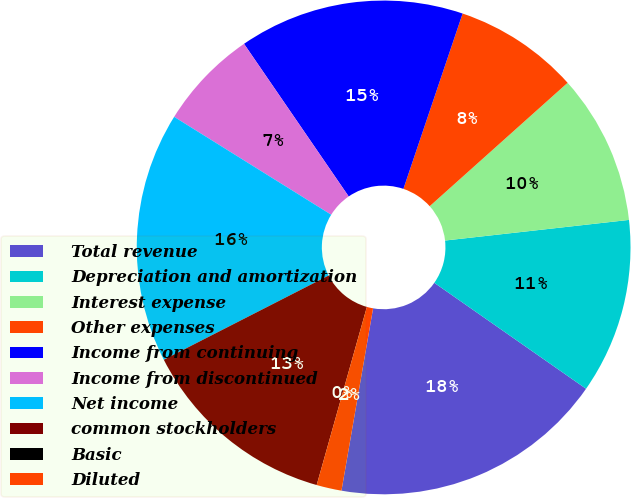<chart> <loc_0><loc_0><loc_500><loc_500><pie_chart><fcel>Total revenue<fcel>Depreciation and amortization<fcel>Interest expense<fcel>Other expenses<fcel>Income from continuing<fcel>Income from discontinued<fcel>Net income<fcel>common stockholders<fcel>Basic<fcel>Diluted<nl><fcel>18.03%<fcel>11.48%<fcel>9.84%<fcel>8.2%<fcel>14.75%<fcel>6.56%<fcel>16.39%<fcel>13.11%<fcel>0.0%<fcel>1.64%<nl></chart> 